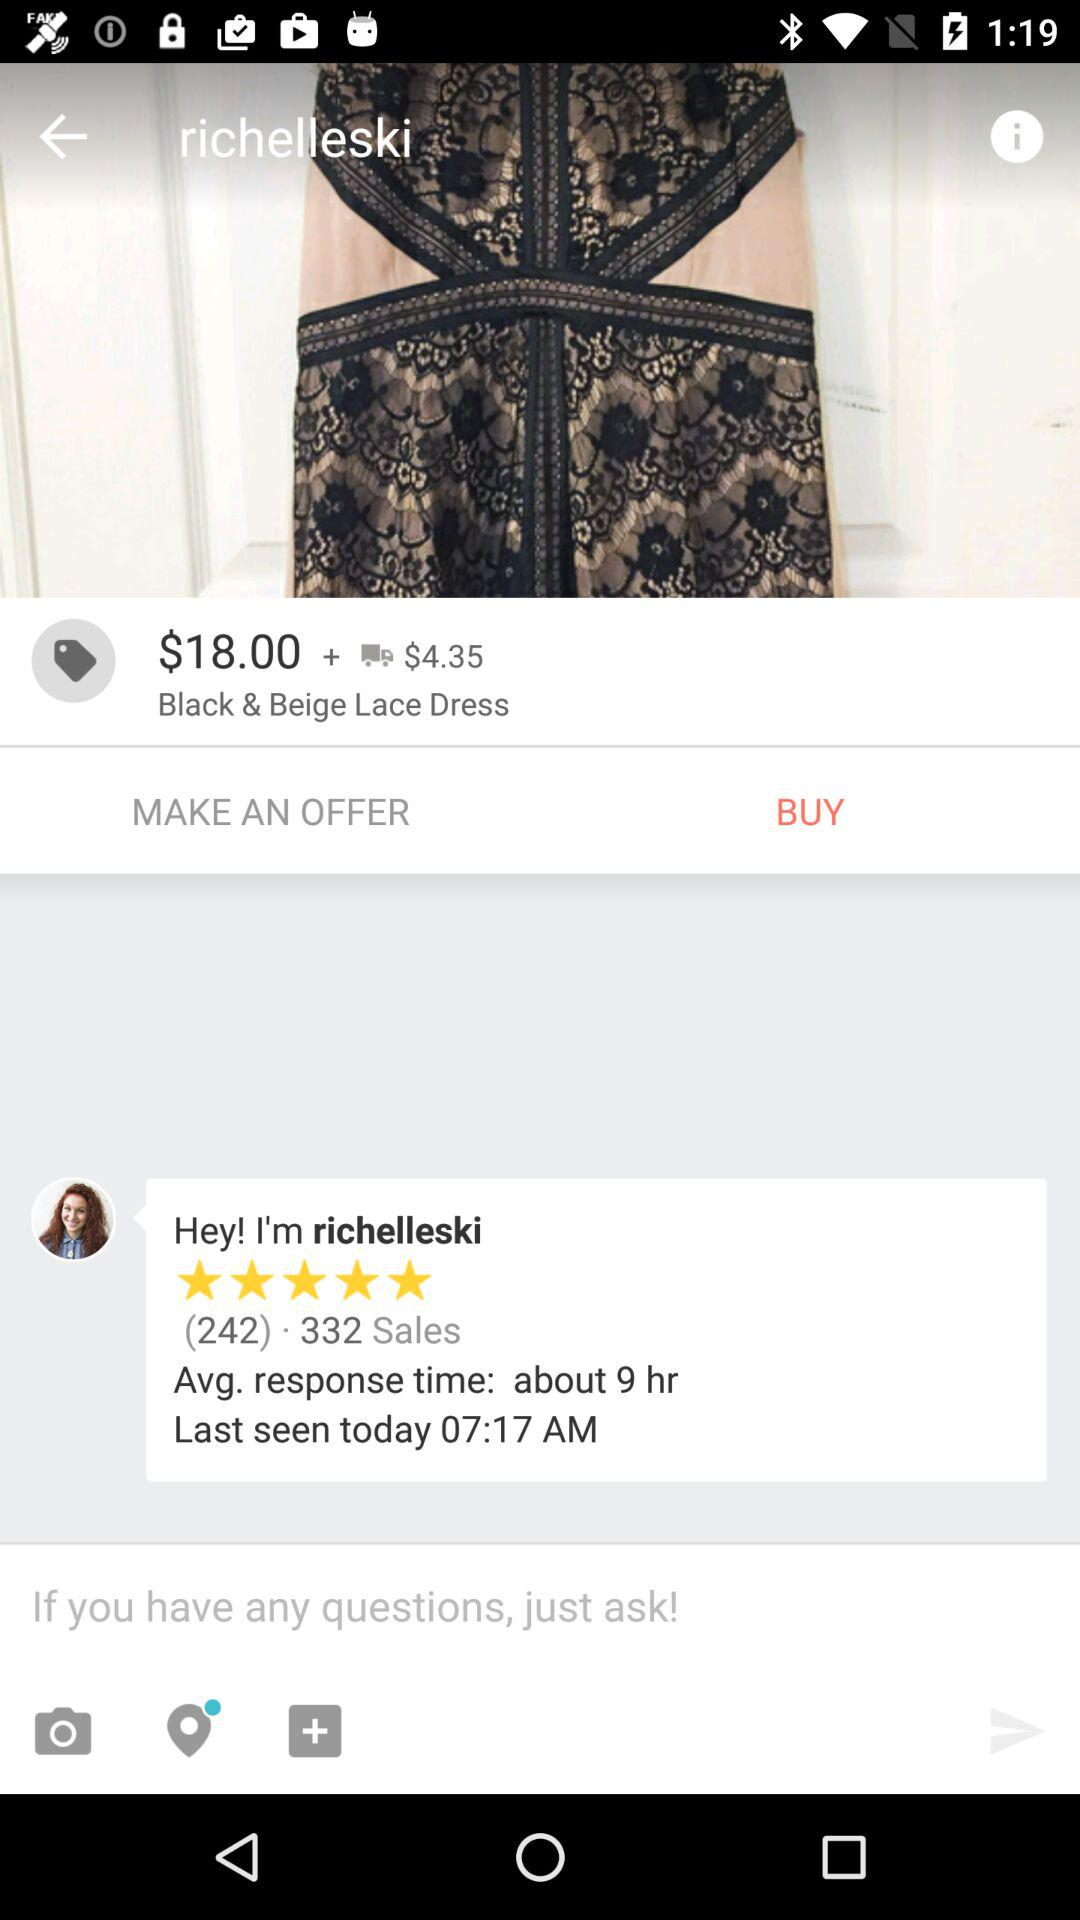What is the average response time by "richelleski"? The average response time by "richelleski" is about 9 hours. 